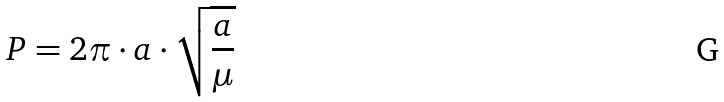Convert formula to latex. <formula><loc_0><loc_0><loc_500><loc_500>P = 2 \pi \cdot a \cdot \sqrt { \frac { a } { \mu } }</formula> 